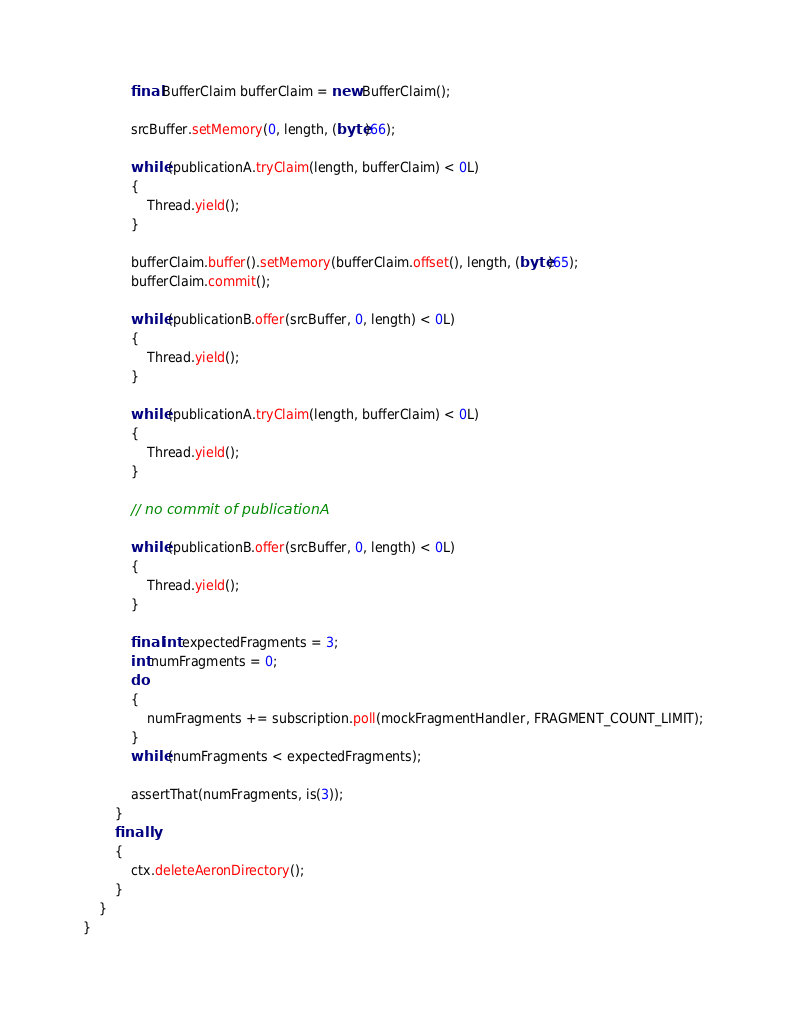Convert code to text. <code><loc_0><loc_0><loc_500><loc_500><_Java_>            final BufferClaim bufferClaim = new BufferClaim();

            srcBuffer.setMemory(0, length, (byte)66);

            while (publicationA.tryClaim(length, bufferClaim) < 0L)
            {
                Thread.yield();
            }

            bufferClaim.buffer().setMemory(bufferClaim.offset(), length, (byte)65);
            bufferClaim.commit();

            while (publicationB.offer(srcBuffer, 0, length) < 0L)
            {
                Thread.yield();
            }

            while (publicationA.tryClaim(length, bufferClaim) < 0L)
            {
                Thread.yield();
            }

            // no commit of publicationA

            while (publicationB.offer(srcBuffer, 0, length) < 0L)
            {
                Thread.yield();
            }

            final int expectedFragments = 3;
            int numFragments = 0;
            do
            {
                numFragments += subscription.poll(mockFragmentHandler, FRAGMENT_COUNT_LIMIT);
            }
            while (numFragments < expectedFragments);

            assertThat(numFragments, is(3));
        }
        finally
        {
            ctx.deleteAeronDirectory();
        }
    }
}
</code> 